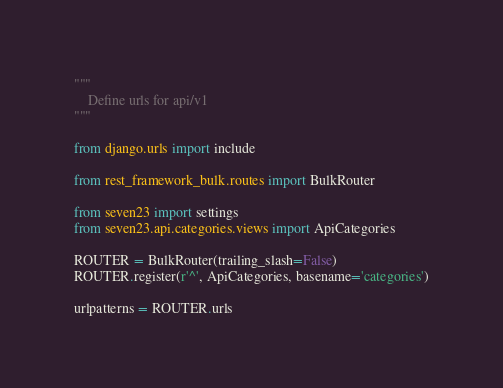<code> <loc_0><loc_0><loc_500><loc_500><_Python_>"""
    Define urls for api/v1
"""

from django.urls import include

from rest_framework_bulk.routes import BulkRouter

from seven23 import settings
from seven23.api.categories.views import ApiCategories

ROUTER = BulkRouter(trailing_slash=False)
ROUTER.register(r'^', ApiCategories, basename='categories')

urlpatterns = ROUTER.urls</code> 